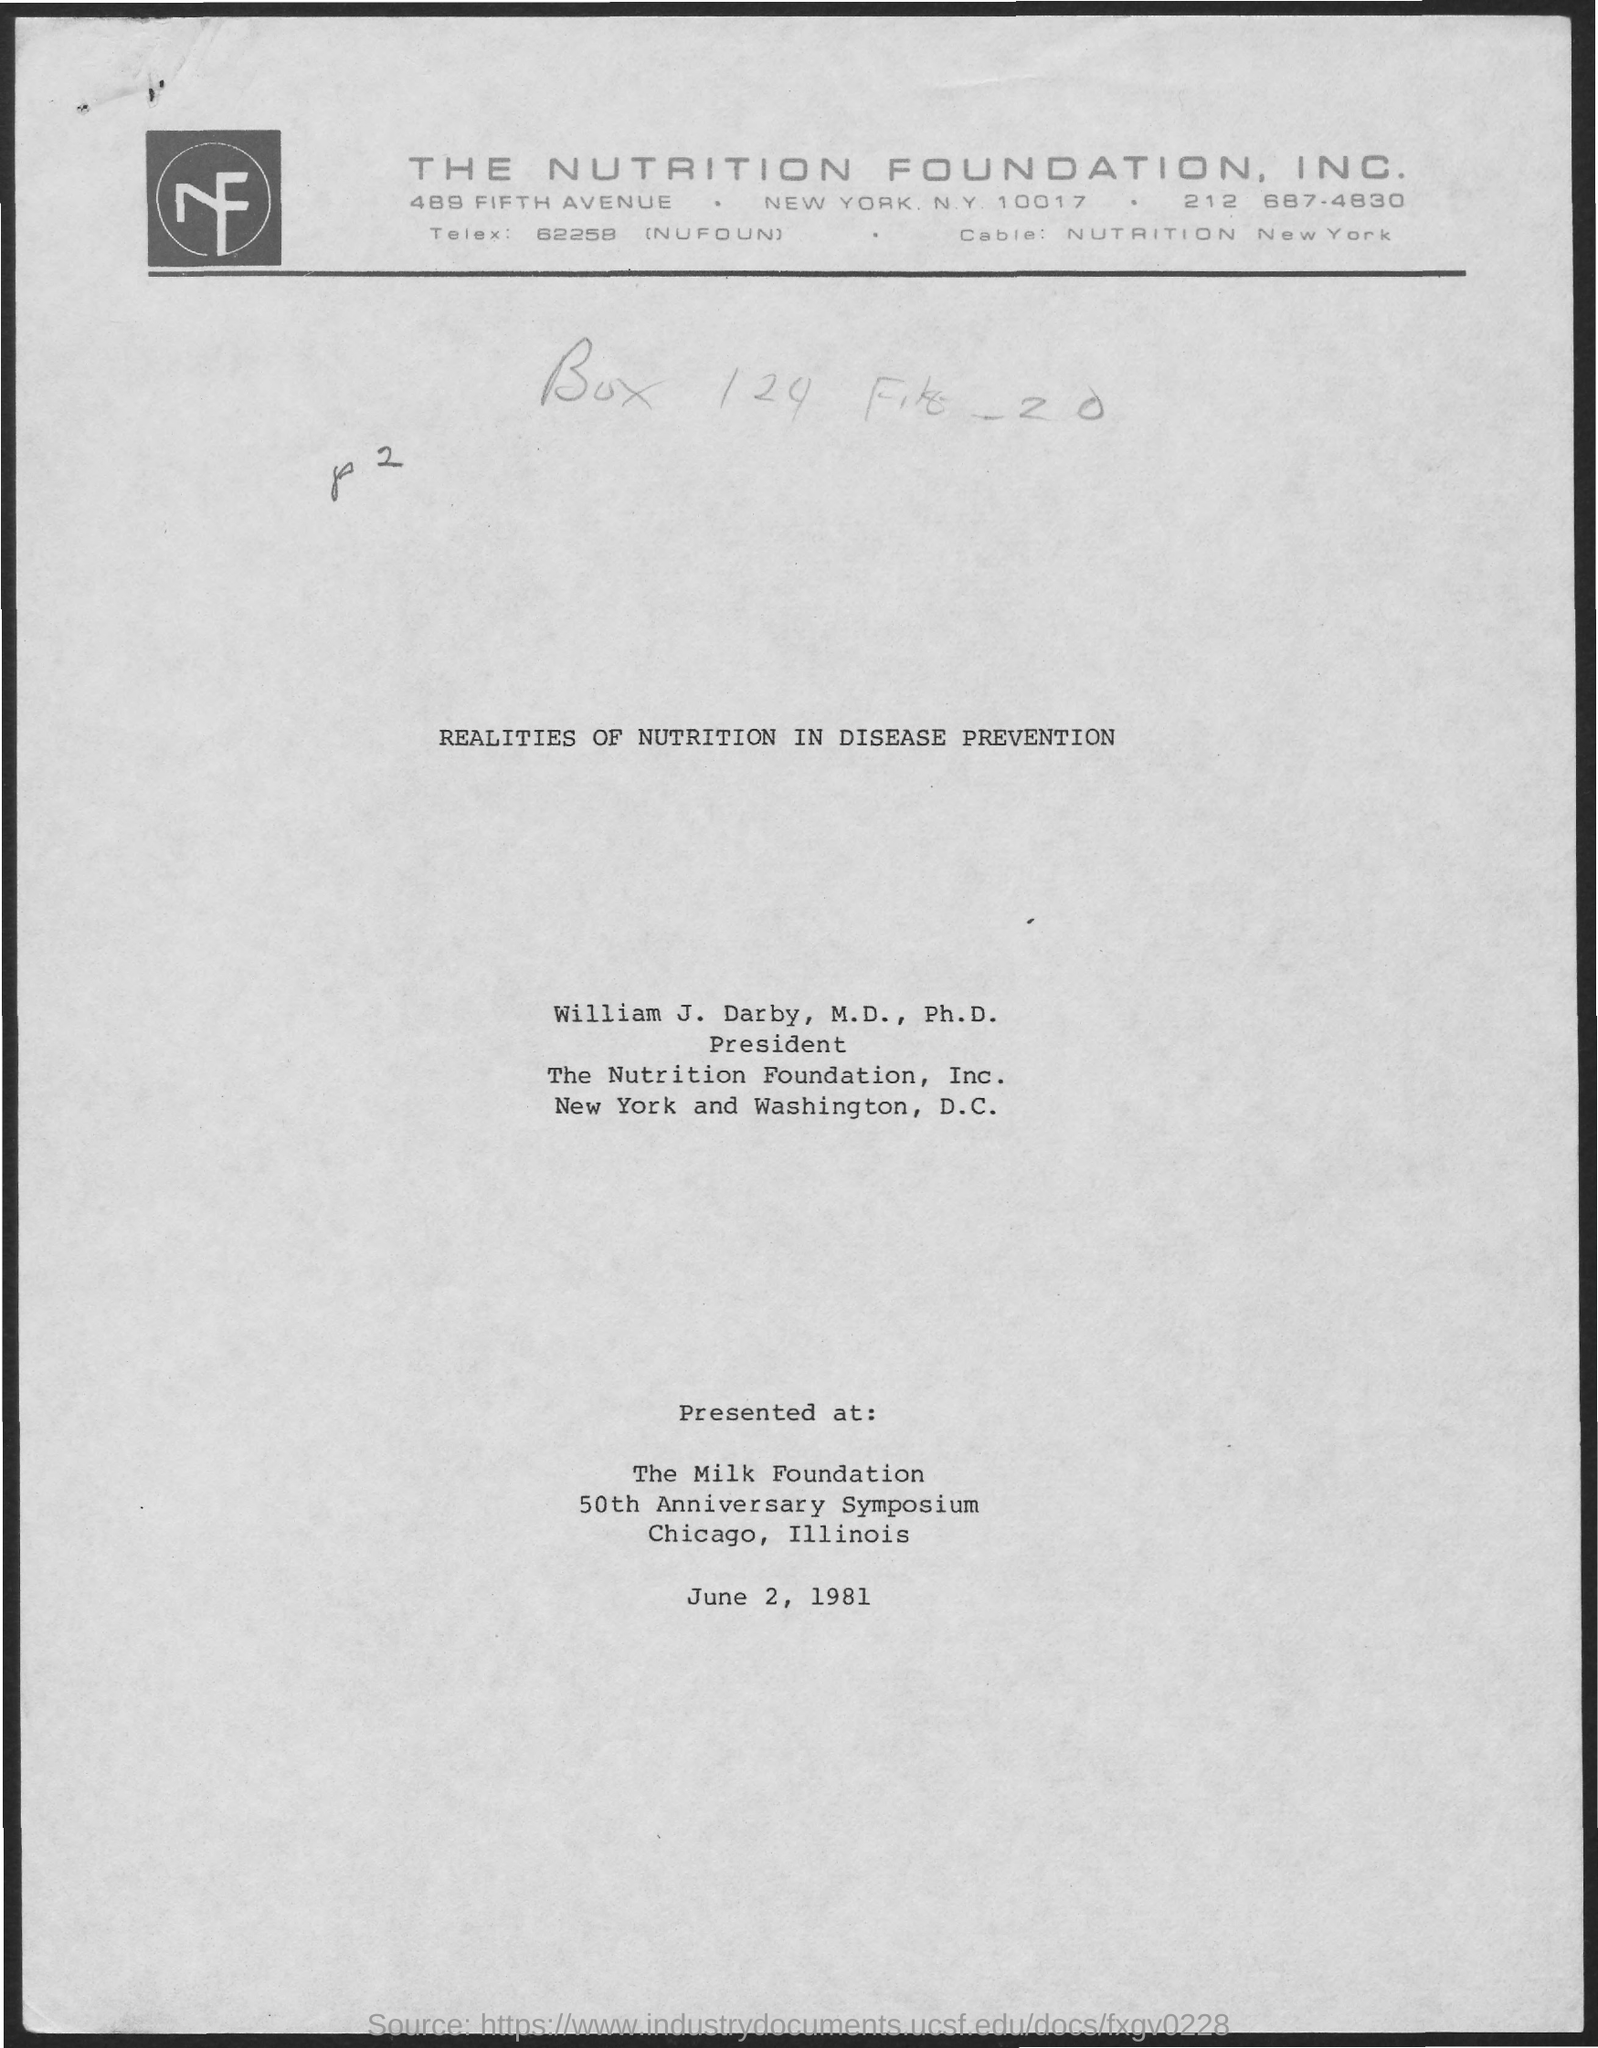Indicate a few pertinent items in this graphic. The date mentioned in the document is June 2, 1981. 